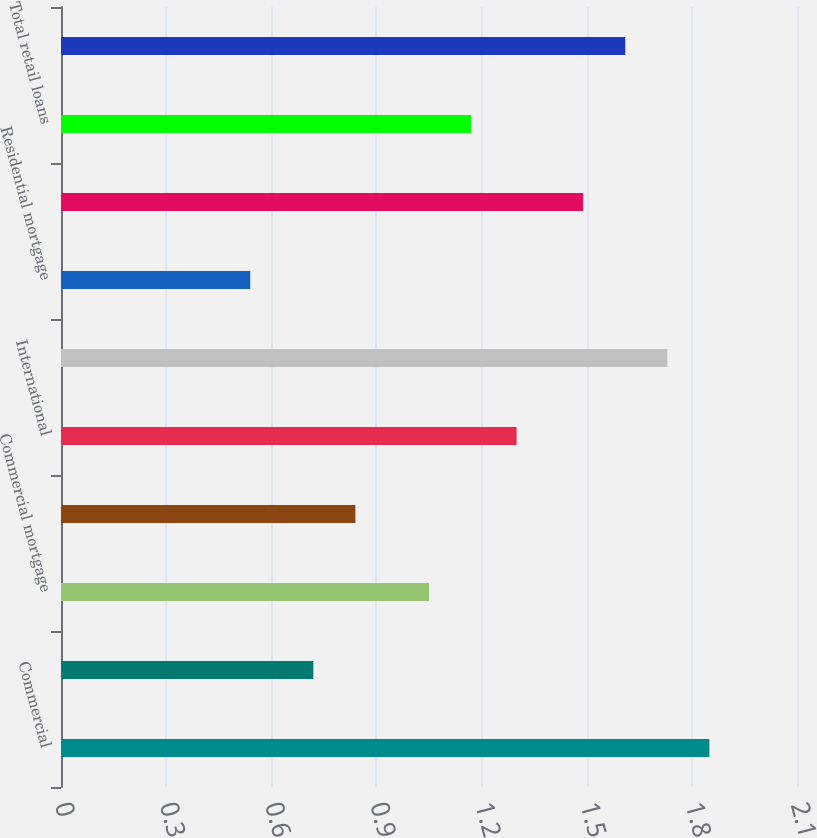Convert chart to OTSL. <chart><loc_0><loc_0><loc_500><loc_500><bar_chart><fcel>Commercial<fcel>Real estate construction<fcel>Commercial mortgage<fcel>Lease financing<fcel>International<fcel>Total business loans<fcel>Residential mortgage<fcel>Consumer<fcel>Total retail loans<fcel>Total loans<nl><fcel>1.85<fcel>0.72<fcel>1.05<fcel>0.84<fcel>1.3<fcel>1.73<fcel>0.54<fcel>1.49<fcel>1.17<fcel>1.61<nl></chart> 